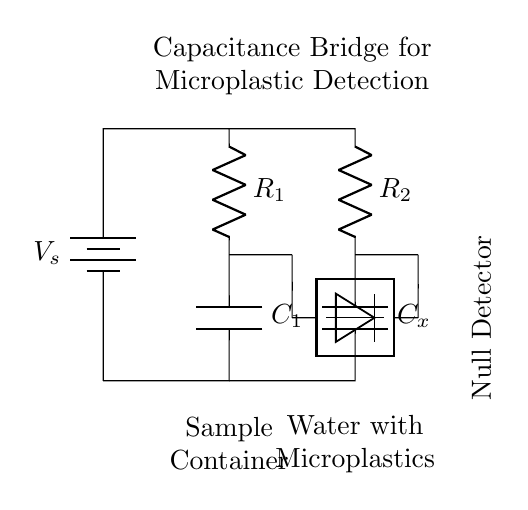What is the power supply voltage in the circuit? The power supply voltage is represented by the symbol V_s at the battery, indicating it is the source voltage for the circuit.
Answer: V_s What are the two resistors labeled in the circuit? The resistors are labeled R_1 and R_2, positioned in the upper part of the circuit diagram, indicating they are part of the capacitance bridge.
Answer: R_1 and R_2 What does the sample container hold? The sample container is labeled explicitly in the diagram and holds a specific type of water sample for analysis related to microplastics.
Answer: Water with Microplastics Which component is used for detecting the null condition? The null detector, marked in the circuit diagram, is specifically designed to identify balance in the capacitance bridge setup.
Answer: Null Detector How many capacitors are present in the capacitance bridge? The circuit diagram displays two capacitors, C_1 and C_x, which are crucial to the operation of the capacitance bridge in detecting changes in capacitance.
Answer: 2 Explain how the two capacitors are connected in the circuit. The two capacitors are connected in a parallel arrangement, where one capacitor, C_1, is in one arm of the bridge, while the second capacitor, C_x, is in the other arm, allowing for comparison of capacitance.
Answer: In parallel 